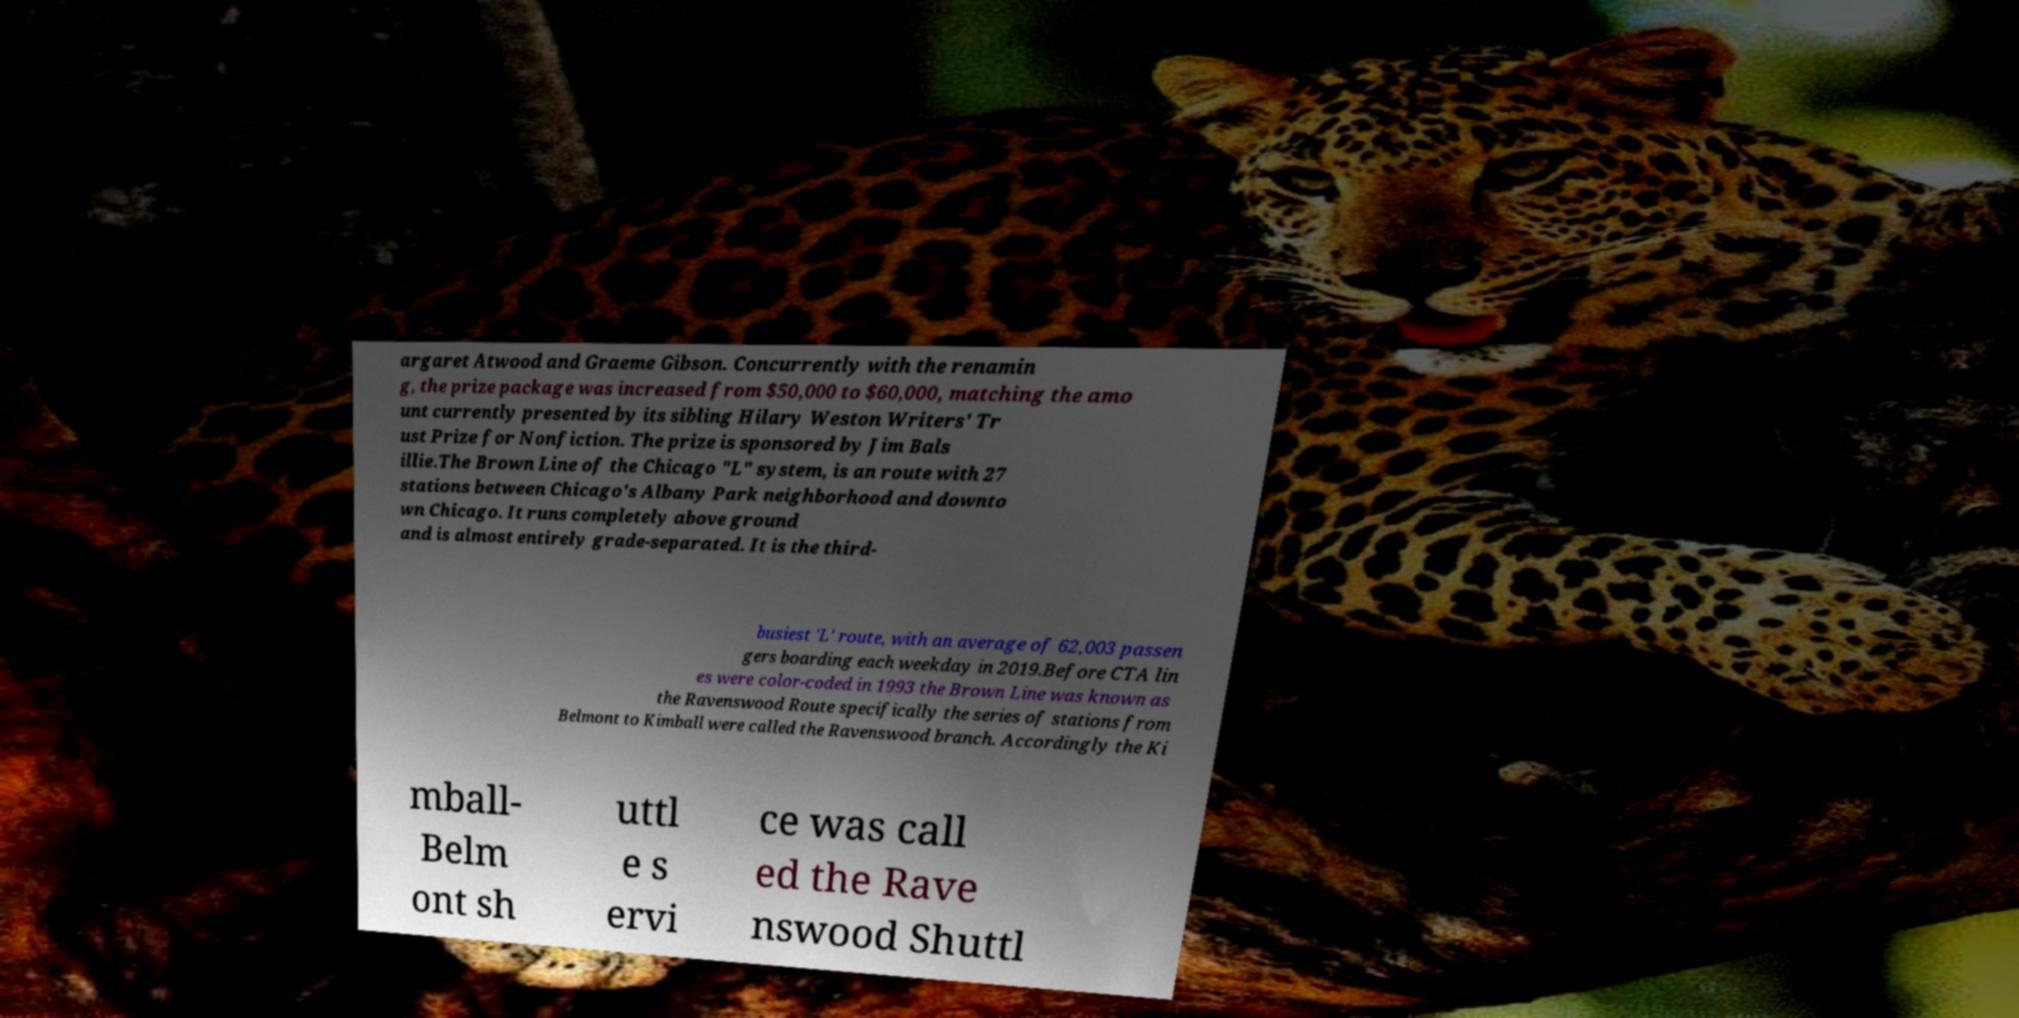Could you assist in decoding the text presented in this image and type it out clearly? argaret Atwood and Graeme Gibson. Concurrently with the renamin g, the prize package was increased from $50,000 to $60,000, matching the amo unt currently presented by its sibling Hilary Weston Writers' Tr ust Prize for Nonfiction. The prize is sponsored by Jim Bals illie.The Brown Line of the Chicago "L" system, is an route with 27 stations between Chicago's Albany Park neighborhood and downto wn Chicago. It runs completely above ground and is almost entirely grade-separated. It is the third- busiest 'L' route, with an average of 62,003 passen gers boarding each weekday in 2019.Before CTA lin es were color-coded in 1993 the Brown Line was known as the Ravenswood Route specifically the series of stations from Belmont to Kimball were called the Ravenswood branch. Accordingly the Ki mball- Belm ont sh uttl e s ervi ce was call ed the Rave nswood Shuttl 